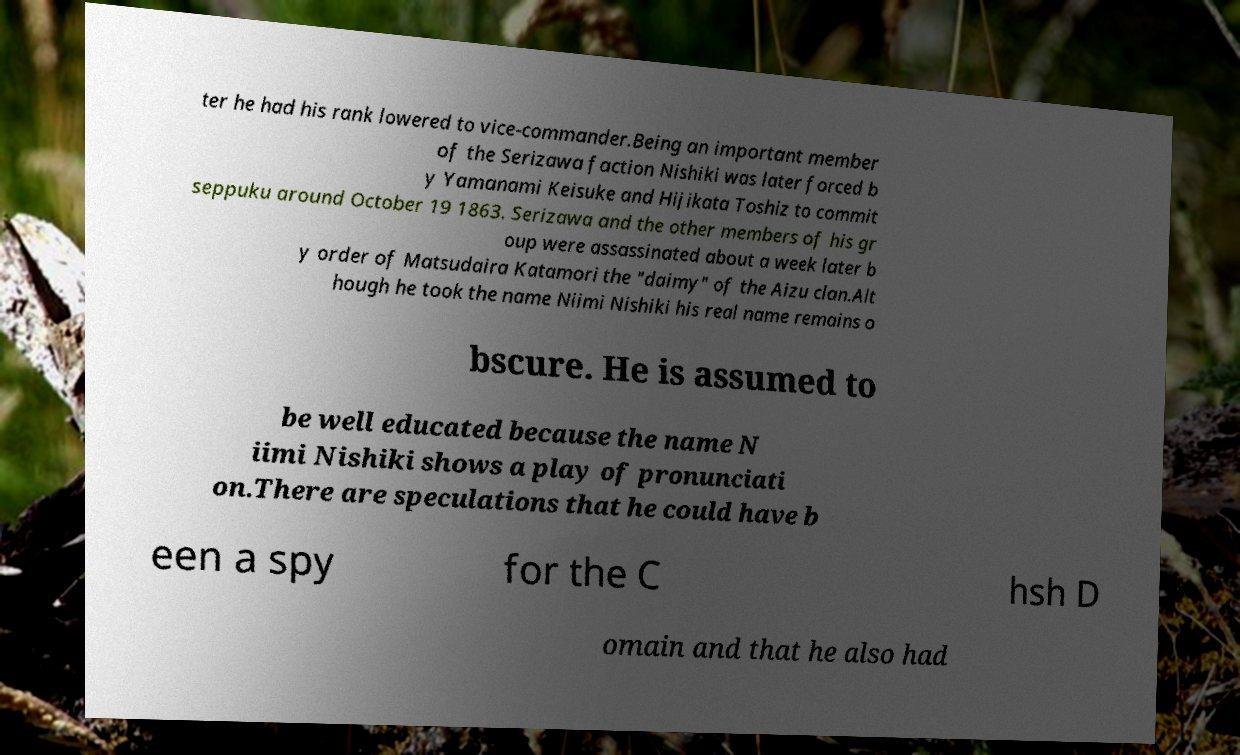Please identify and transcribe the text found in this image. ter he had his rank lowered to vice-commander.Being an important member of the Serizawa faction Nishiki was later forced b y Yamanami Keisuke and Hijikata Toshiz to commit seppuku around October 19 1863. Serizawa and the other members of his gr oup were assassinated about a week later b y order of Matsudaira Katamori the "daimy" of the Aizu clan.Alt hough he took the name Niimi Nishiki his real name remains o bscure. He is assumed to be well educated because the name N iimi Nishiki shows a play of pronunciati on.There are speculations that he could have b een a spy for the C hsh D omain and that he also had 